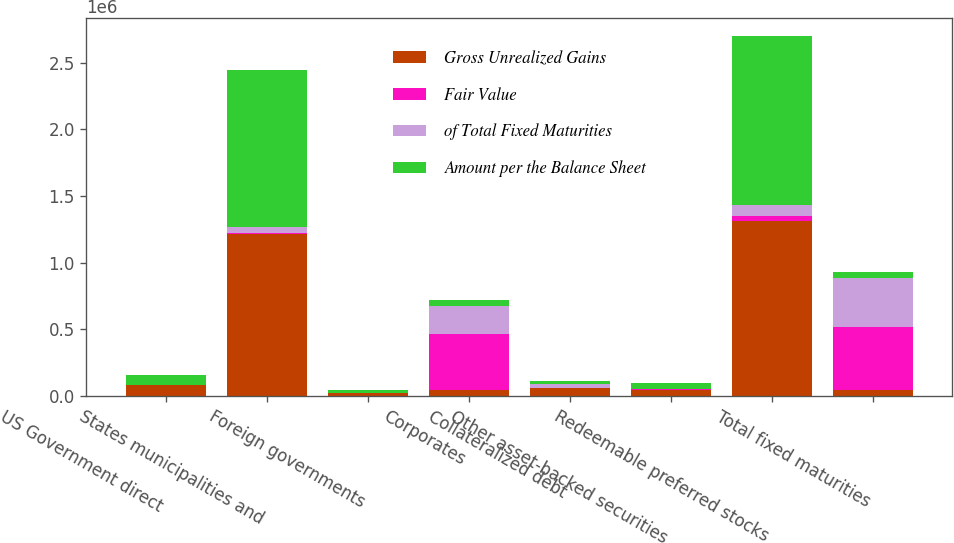Convert chart to OTSL. <chart><loc_0><loc_0><loc_500><loc_500><stacked_bar_chart><ecel><fcel>US Government direct<fcel>States municipalities and<fcel>Foreign governments<fcel>Corporates<fcel>Collateralized debt<fcel>Other asset-backed securities<fcel>Redeemable preferred stocks<fcel>Total fixed maturities<nl><fcel>Gross Unrealized Gains<fcel>78387<fcel>1.21218e+06<fcel>22352<fcel>44108.5<fcel>56525<fcel>46406<fcel>1.3117e+06<fcel>44108.5<nl><fcel>Fair Value<fcel>1347<fcel>10752<fcel>679<fcel>423076<fcel>0<fcel>3010<fcel>36405<fcel>475269<nl><fcel>of Total Fixed Maturities<fcel>1060<fcel>41811<fcel>0<fcel>210149<fcel>34069<fcel>678<fcel>79965<fcel>367732<nl><fcel>Amount per the Balance Sheet<fcel>78674<fcel>1.18113e+06<fcel>23031<fcel>44108.5<fcel>22456<fcel>48738<fcel>1.26814e+06<fcel>44108.5<nl></chart> 